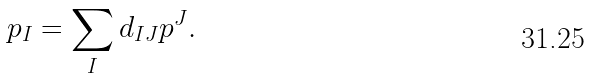<formula> <loc_0><loc_0><loc_500><loc_500>p _ { I } = \sum _ { I } d _ { I J } p ^ { J } .</formula> 